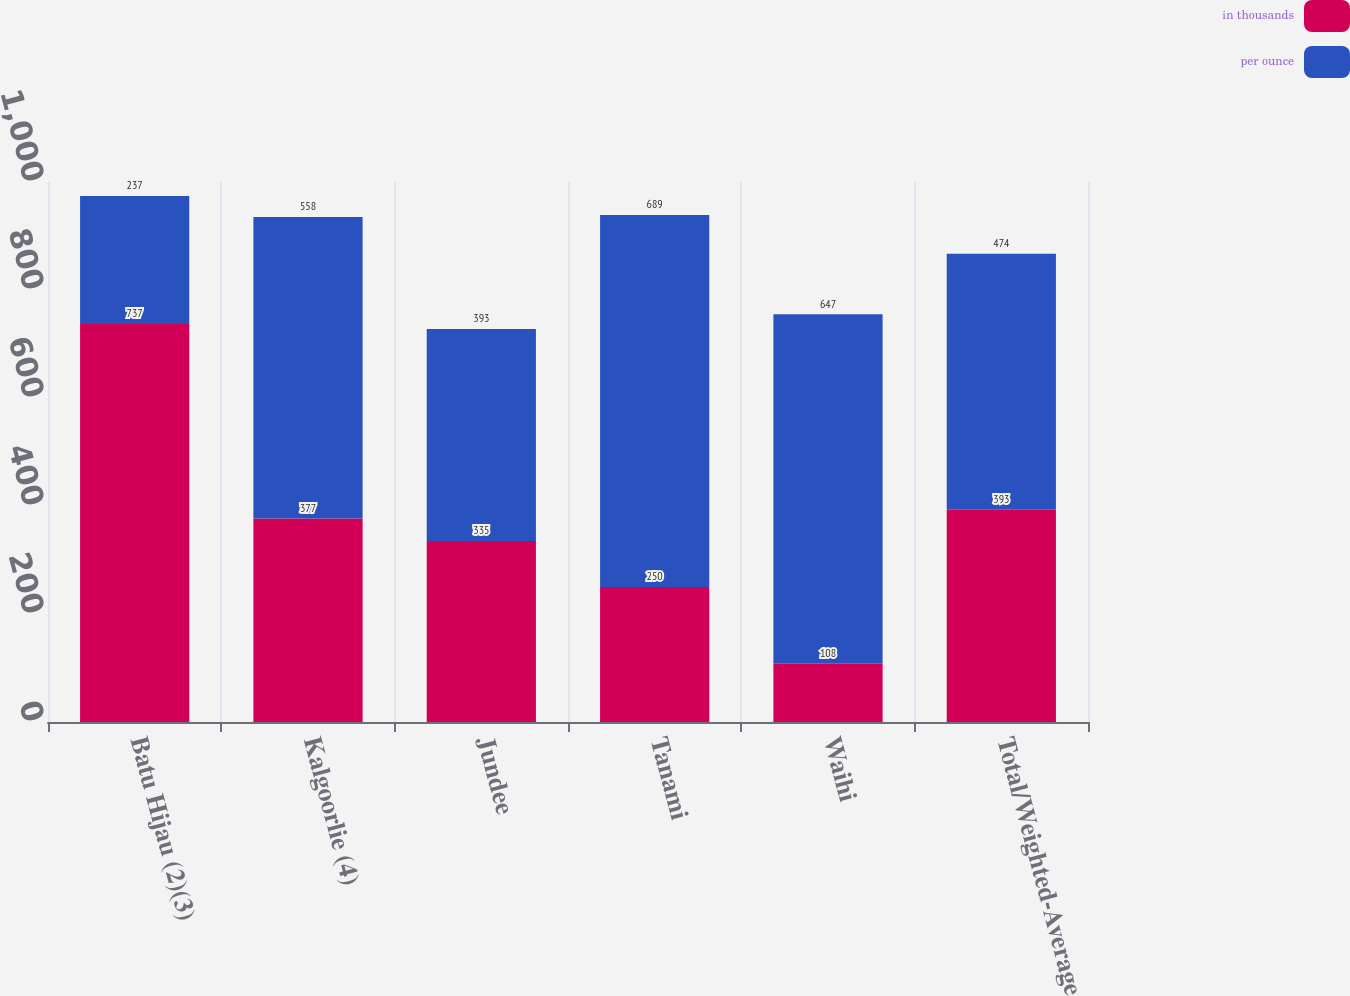Convert chart to OTSL. <chart><loc_0><loc_0><loc_500><loc_500><stacked_bar_chart><ecel><fcel>Batu Hijau (2)(3)<fcel>Kalgoorlie (4)<fcel>Jundee<fcel>Tanami<fcel>Waihi<fcel>Total/Weighted-Average<nl><fcel>in thousands<fcel>737<fcel>377<fcel>335<fcel>250<fcel>108<fcel>393<nl><fcel>per ounce<fcel>237<fcel>558<fcel>393<fcel>689<fcel>647<fcel>474<nl></chart> 